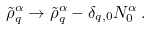<formula> <loc_0><loc_0><loc_500><loc_500>\tilde { \rho } ^ { \alpha } _ { q } \rightarrow \tilde { \rho } ^ { \alpha } _ { q } - \delta _ { q , 0 } N ^ { \alpha } _ { 0 } \, .</formula> 